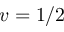<formula> <loc_0><loc_0><loc_500><loc_500>v = 1 / 2</formula> 